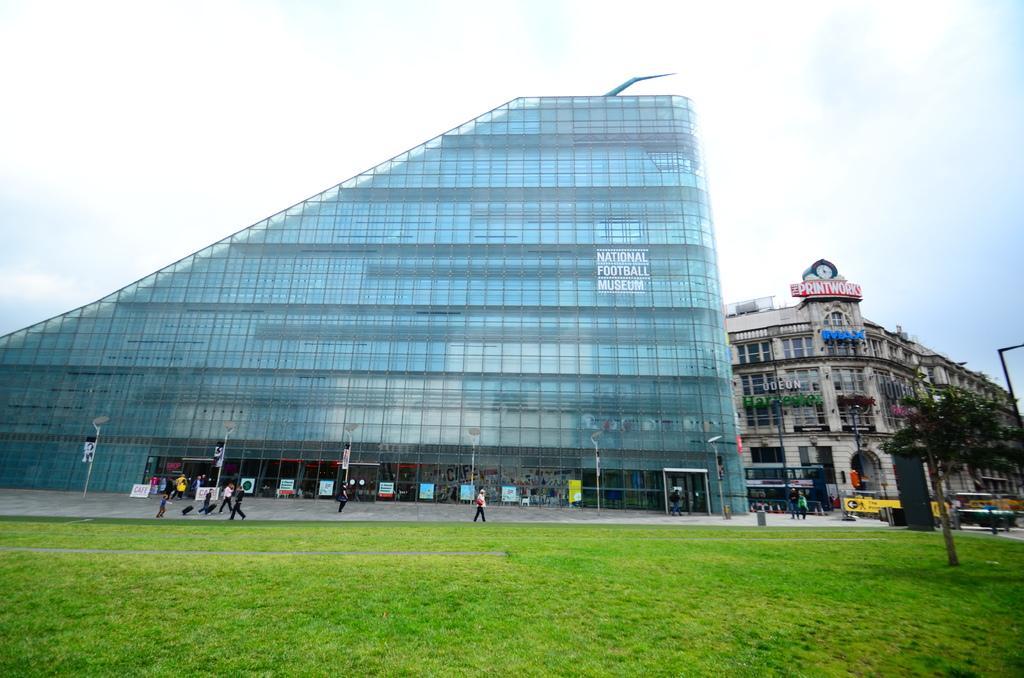How would you summarize this image in a sentence or two? In this picture there is a commercial building in the center of the image and there is another building on the right side of the image, there is grassland at the bottom side of the image and there are people, posters, vehicles, and poles at the bottom side of the image. 